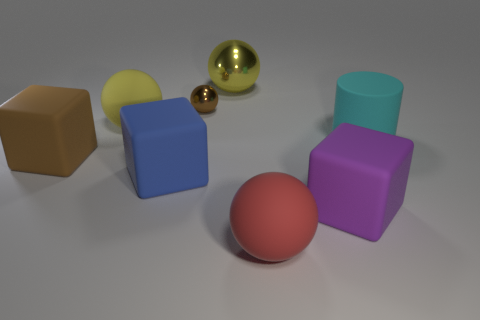What number of big rubber blocks have the same color as the small metal ball?
Keep it short and to the point. 1. What is the size of the yellow object on the right side of the tiny brown thing?
Keep it short and to the point. Large. There is a cyan matte thing that is in front of the large rubber thing behind the thing that is to the right of the big purple block; what is its shape?
Your answer should be compact. Cylinder. The big rubber thing that is on the left side of the small brown sphere and in front of the big brown cube has what shape?
Your answer should be compact. Cube. Is there a yellow rubber thing of the same size as the rubber cylinder?
Ensure brevity in your answer.  Yes. There is a large yellow object that is on the right side of the large yellow matte sphere; is its shape the same as the small brown thing?
Provide a succinct answer. Yes. Do the large red matte object and the big purple matte object have the same shape?
Offer a terse response. No. Are there any red metal things of the same shape as the big blue matte object?
Offer a terse response. No. What shape is the matte thing that is behind the rubber thing that is on the right side of the big purple cube?
Ensure brevity in your answer.  Sphere. What is the color of the big sphere that is on the left side of the blue rubber cube?
Provide a short and direct response. Yellow. 